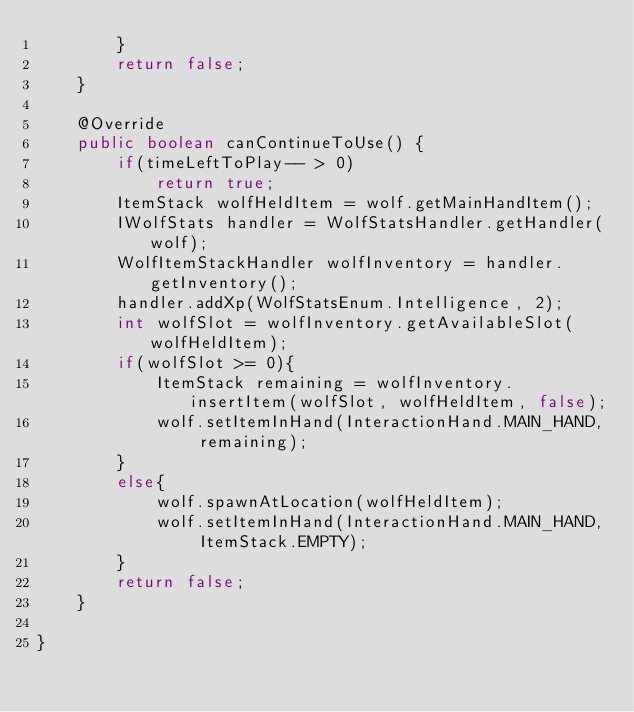<code> <loc_0><loc_0><loc_500><loc_500><_Java_>        }
        return false;
    }

    @Override
    public boolean canContinueToUse() {
        if(timeLeftToPlay-- > 0)
            return true;
        ItemStack wolfHeldItem = wolf.getMainHandItem();
        IWolfStats handler = WolfStatsHandler.getHandler(wolf);
        WolfItemStackHandler wolfInventory = handler.getInventory();
        handler.addXp(WolfStatsEnum.Intelligence, 2);
        int wolfSlot = wolfInventory.getAvailableSlot(wolfHeldItem);
        if(wolfSlot >= 0){
            ItemStack remaining = wolfInventory.insertItem(wolfSlot, wolfHeldItem, false);
            wolf.setItemInHand(InteractionHand.MAIN_HAND, remaining);
        }
        else{
            wolf.spawnAtLocation(wolfHeldItem);                    
            wolf.setItemInHand(InteractionHand.MAIN_HAND, ItemStack.EMPTY);
        }
        return false;
    }
    
}
</code> 